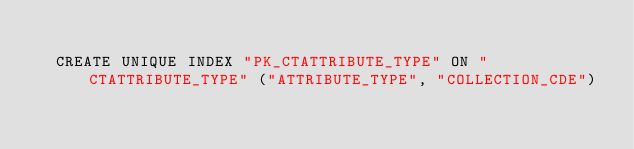Convert code to text. <code><loc_0><loc_0><loc_500><loc_500><_SQL_>
  CREATE UNIQUE INDEX "PK_CTATTRIBUTE_TYPE" ON "CTATTRIBUTE_TYPE" ("ATTRIBUTE_TYPE", "COLLECTION_CDE") 
  </code> 